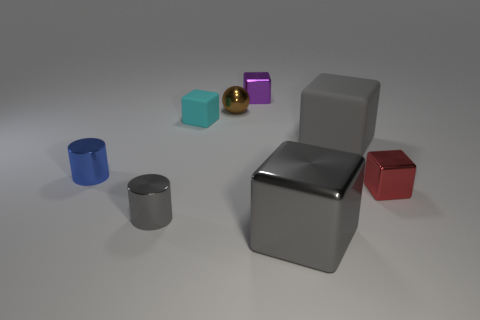Subtract all small purple cubes. How many cubes are left? 4 Subtract all purple blocks. How many blocks are left? 4 Subtract all brown blocks. Subtract all purple balls. How many blocks are left? 5 Add 1 big matte things. How many objects exist? 9 Subtract all spheres. How many objects are left? 7 Subtract 0 cyan spheres. How many objects are left? 8 Subtract all green cubes. Subtract all cyan matte objects. How many objects are left? 7 Add 7 small red objects. How many small red objects are left? 8 Add 7 gray rubber cubes. How many gray rubber cubes exist? 8 